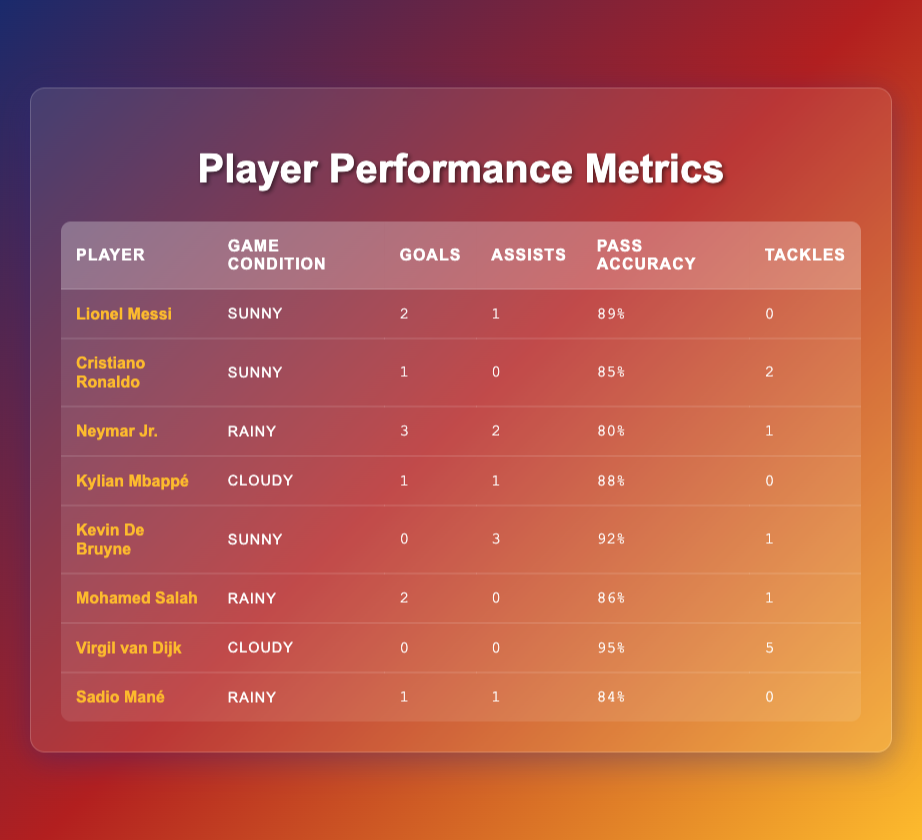What is the highest number of goals scored by a player in rainy conditions? Neymar Jr. scored 3 goals in rainy conditions. The other rainy condition players were Mohamed Salah with 2 goals and Sadio Mané with 1 goal. Thus, the highest is 3.
Answer: 3 Who has the highest pass accuracy in sunny conditions? In sunny conditions, Kevin De Bruyne has the highest pass accuracy at 92%. Lionel Messi follows with 89% and Cristiano Ronaldo with 85%.
Answer: 92% How many assists did Kylian Mbappé have in cloudy conditions? Kylian Mbappé had 1 assist in cloudy conditions according to the table.
Answer: 1 Is it true that Virgil van Dijk scored any goals in cloudy conditions? According to the table, Virgil van Dijk did not score any goals in cloudy conditions; he has 0 goals listed.
Answer: Yes What is the total number of assists made by players in rainy conditions? In rainy conditions, Neymar Jr. had 2 assists, Mohamed Salah had 0 assists, and Sadio Mané had 1 assist. Adding these together gives 2 + 0 + 1 = 3 assists total.
Answer: 3 Who scored the least number of goals in this dataset? Virgil van Dijk scored 0 goals, which is the least in this dataset.
Answer: 0 What was the average pass accuracy of players under rainy conditions? The players in rainy conditions are Neymar Jr. (80%), Mohamed Salah (86%), and Sadio Mané (84%). The average is calculated as (80 + 86 + 84) / 3 = 250 / 3 = 83.33%.
Answer: 83.33% Which player had the most tackles overall? The player with the most tackles is Virgil van Dijk, who made 5 tackles, as listed in the table.
Answer: 5 